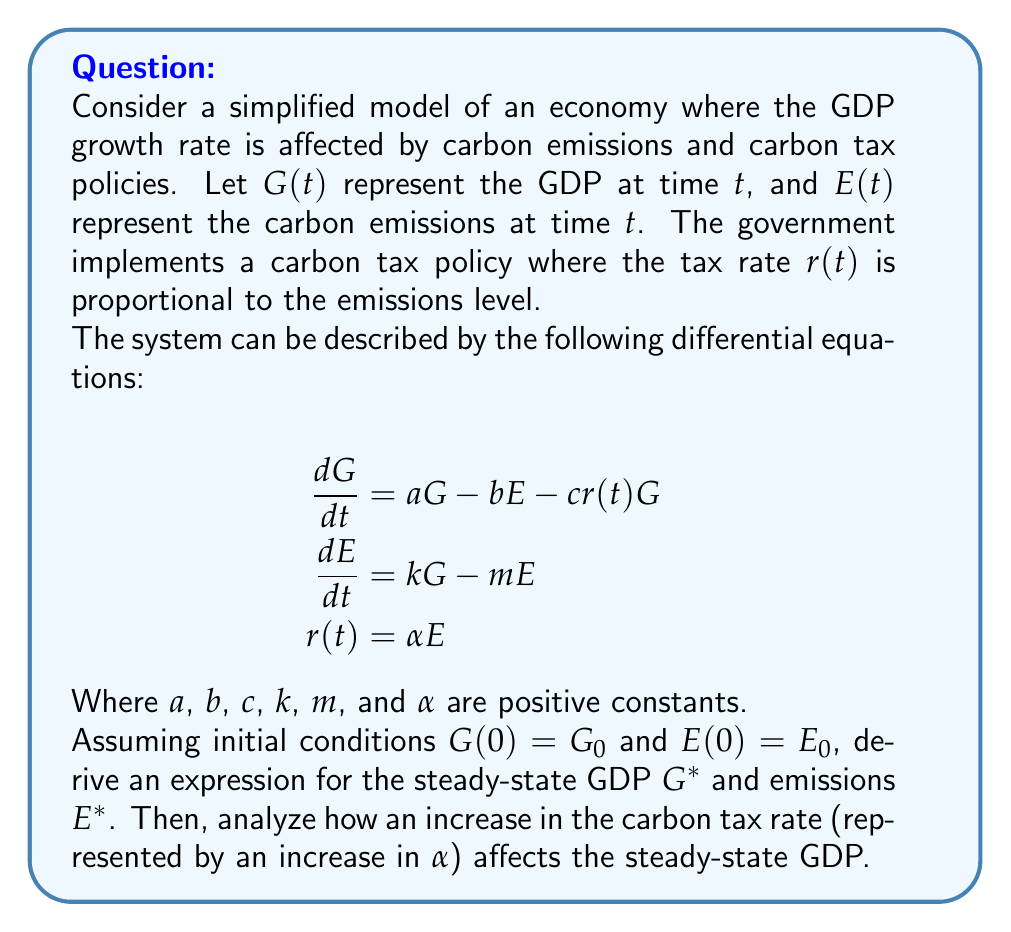Could you help me with this problem? Let's approach this step-by-step:

1) First, we need to find the steady-state values. At steady-state, the rates of change are zero:

   $$\frac{dG}{dt} = 0$$ and $$\frac{dE}{dt} = 0$$

2) From the second equation:
   
   $$0 = kG^* - mE^*$$
   $$E^* = \frac{k}{m}G^*$$

3) Substituting this into the first equation:

   $$0 = aG^* - b(\frac{k}{m}G^*) - c\alpha(\frac{k}{m}G^*)G^*$$
   $$0 = aG^* - \frac{bk}{m}G^* - \frac{c\alpha k}{m}(G^*)^2$$

4) Factoring out $G^*$:

   $$0 = G^*(a - \frac{bk}{m} - \frac{c\alpha k}{m}G^*)$$

5) Solving for $G^*$:

   $$G^* = 0$$ or $$G^* = \frac{am - bk}{c\alpha k}$$

   The non-zero solution is the economically relevant one.

6) To find $E^*$, we substitute this back into the equation from step 2:

   $$E^* = \frac{k}{m}(\frac{am - bk}{c\alpha k}) = \frac{am - bk}{c\alpha m}$$

7) To analyze how an increase in $\alpha$ affects the steady-state GDP, we take the derivative of $G^*$ with respect to $\alpha$:

   $$\frac{dG^*}{d\alpha} = \frac{d}{d\alpha}(\frac{am - bk}{c\alpha k}) = -\frac{am - bk}{c\alpha^2 k}$$

8) This derivative is negative (remember, all constants are positive), which means that as $\alpha$ increases, $G^*$ decreases.

Therefore, an increase in the carbon tax rate (represented by an increase in $\alpha$) leads to a decrease in the steady-state GDP.
Answer: $G^* = \frac{am - bk}{c\alpha k}$, $E^* = \frac{am - bk}{c\alpha m}$. Increasing $\alpha$ decreases $G^*$. 